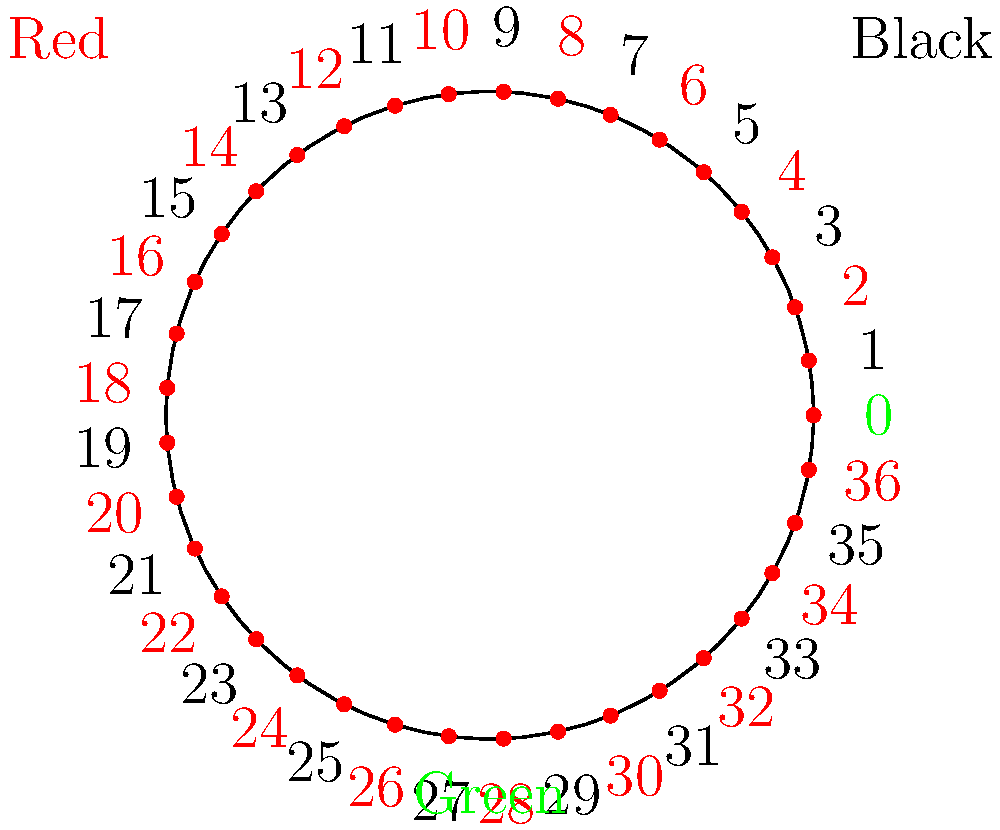As a croupier at Casino Gran Madrid, you're often asked about roulette strategies. A player suggests betting on red for 10 consecutive spins, doubling their bet after each loss (Martingale system). What is the probability of this strategy being successful (winning at least once) on a European roulette wheel? Let's approach this step-by-step:

1) In European roulette, there are 37 numbers: 18 red, 18 black, and 1 green (0).

2) The probability of winning on a single red bet is:
   $P(\text{red}) = \frac{18}{37} \approx 0.4865$

3) The probability of losing on a single red bet is:
   $P(\text{not red}) = 1 - \frac{18}{37} = \frac{19}{37} \approx 0.5135$

4) For the strategy to fail, the player must lose 10 times in a row. The probability of this is:
   $P(\text{10 losses}) = (\frac{19}{37})^{10} \approx 0.0016$

5) Therefore, the probability of winning at least once in 10 spins is:
   $P(\text{win at least once}) = 1 - P(\text{10 losses}) = 1 - (\frac{19}{37})^{10} \approx 0.9984$

6) Convert to percentage: $0.9984 * 100\% = 99.84\%$

This high probability might make the strategy seem attractive, but it's important to note that the potential losses in case of a losing streak can be extremely high due to the doubling of bets.
Answer: 99.84% 